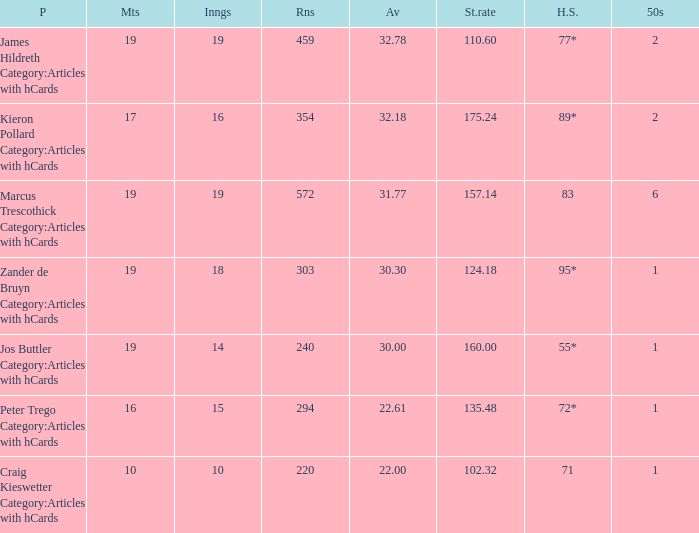What is the highest score for the player with average of 30.00? 55*. 